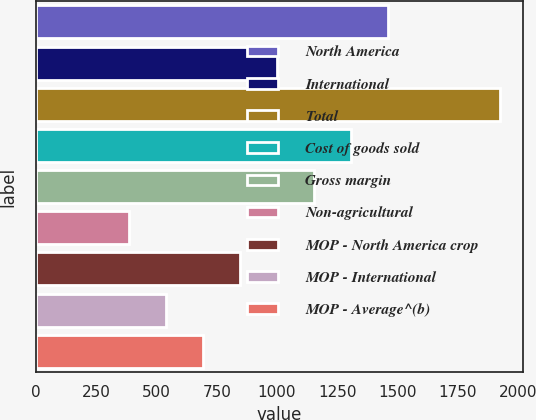<chart> <loc_0><loc_0><loc_500><loc_500><bar_chart><fcel>North America<fcel>International<fcel>Total<fcel>Cost of goods sold<fcel>Gross margin<fcel>Non-agricultural<fcel>MOP - North America crop<fcel>MOP - International<fcel>MOP - Average^(b)<nl><fcel>1462.42<fcel>1000.24<fcel>1924.6<fcel>1308.36<fcel>1154.3<fcel>384<fcel>846.18<fcel>538.06<fcel>692.12<nl></chart> 